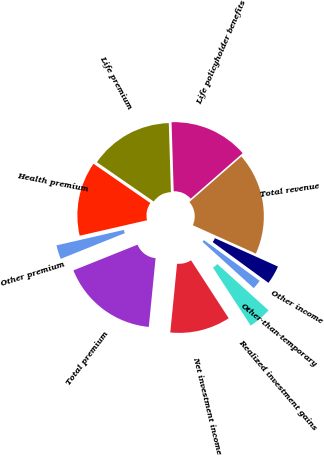Convert chart. <chart><loc_0><loc_0><loc_500><loc_500><pie_chart><fcel>Life premium<fcel>Health premium<fcel>Other premium<fcel>Total premium<fcel>Net investment income<fcel>Realized investment gains<fcel>Other-than-temporary<fcel>Other income<fcel>Total revenue<fcel>Life policyholder benefits<nl><fcel>14.88%<fcel>13.22%<fcel>2.48%<fcel>17.36%<fcel>10.74%<fcel>4.13%<fcel>1.65%<fcel>3.31%<fcel>18.18%<fcel>14.05%<nl></chart> 